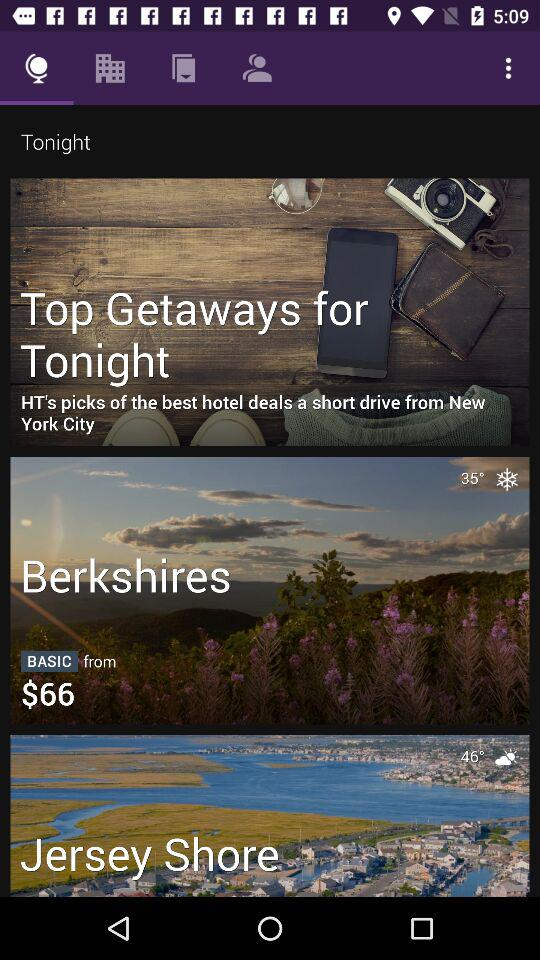What is the temperature in the Berkshires? The temperature is 35°. 